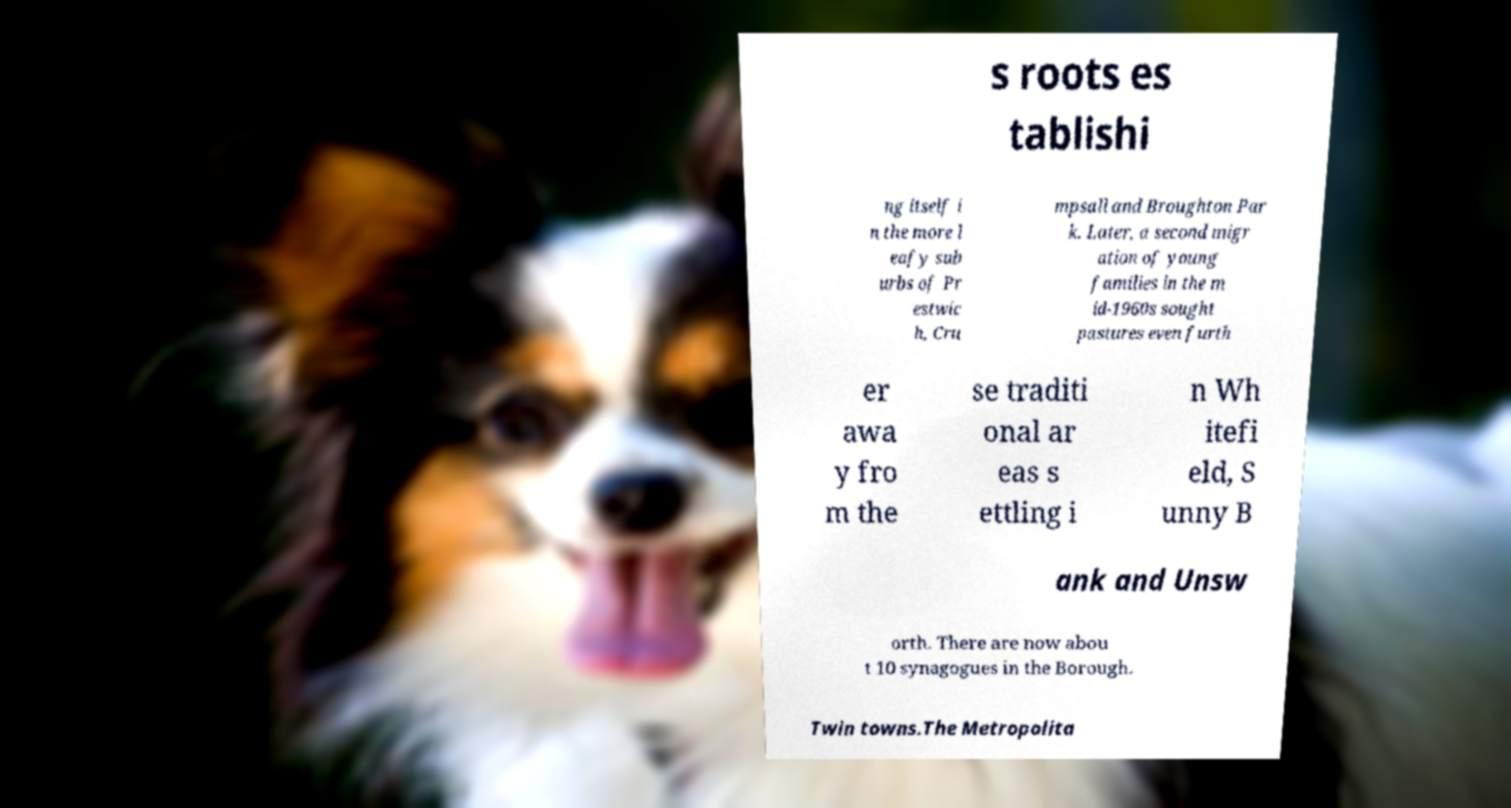What messages or text are displayed in this image? I need them in a readable, typed format. s roots es tablishi ng itself i n the more l eafy sub urbs of Pr estwic h, Cru mpsall and Broughton Par k. Later, a second migr ation of young families in the m id-1960s sought pastures even furth er awa y fro m the se traditi onal ar eas s ettling i n Wh itefi eld, S unny B ank and Unsw orth. There are now abou t 10 synagogues in the Borough. Twin towns.The Metropolita 